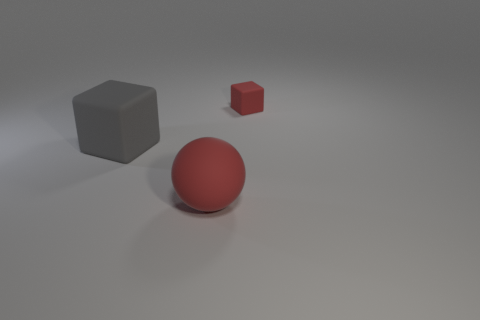Is the number of small red objects on the right side of the red cube the same as the number of small purple balls?
Your response must be concise. Yes. What is the material of the big thing in front of the gray matte thing that is behind the red object that is left of the tiny thing?
Offer a very short reply. Rubber. There is another thing that is the same color as the tiny object; what material is it?
Ensure brevity in your answer.  Rubber. How many things are large rubber objects that are behind the big rubber sphere or big cylinders?
Your answer should be very brief. 1. What number of objects are big gray matte cubes or large objects to the left of the large red ball?
Provide a succinct answer. 1. There is a red thing behind the ball to the left of the tiny cube; what number of big matte balls are on the left side of it?
Give a very brief answer. 1. What is the material of the gray cube that is the same size as the red ball?
Ensure brevity in your answer.  Rubber. Is there a red thing of the same size as the red sphere?
Your answer should be compact. No. What color is the big block?
Your answer should be compact. Gray. There is a rubber block in front of the red rubber object behind the gray matte block; what is its color?
Your answer should be very brief. Gray. 